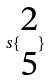Convert formula to latex. <formula><loc_0><loc_0><loc_500><loc_500>s \{ \begin{matrix} 2 \\ 5 \end{matrix} \}</formula> 